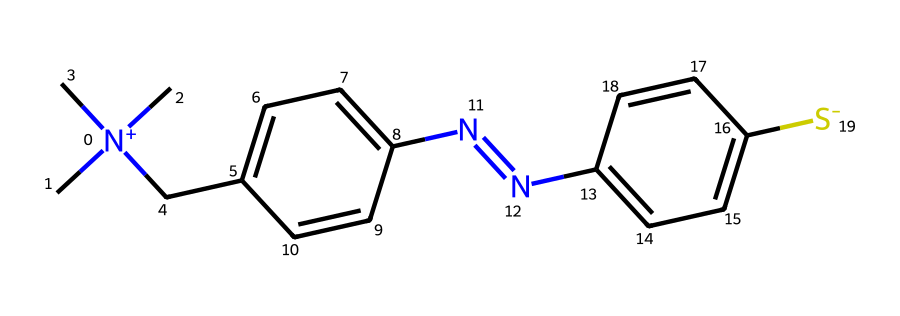What is the charge of the nitrogen atom in this ionic liquid? The nitrogen atom in the structure is part of the quaternary ammonium group, which indicates it carries a positive charge.
Answer: positive How many rings are present in the chemical structure? By analyzing the chemical structure, there are two distinct cyclic structures indicated by the presence of double bonds and cyclic connectivity: one ring on the left and one on the right.
Answer: 2 What functional group is represented by the sulfonium part of the structure? The presence of sulfur (indicated by S-) within the structure suggests that this ionic liquid contains a sulfonium functional group, which is characteristic of ionic liquids for its unique properties.
Answer: sulfonium Identify the overall type of ionic liquid based on its anion composition. The chemical contains a sulfonium center combined with a nitrogenous cation, and thus, the composition implies it could be classified as a protic ionic liquid, specifically due to its ammonium association with the sulfonium anion.
Answer: protic ionic liquid How many carbon atoms are part of the cation component? By counting the carbon atoms in the structure's cation (which is attached to the quaternary nitrogen), we can determine that there are seven carbon atoms in total within that segment.
Answer: 7 